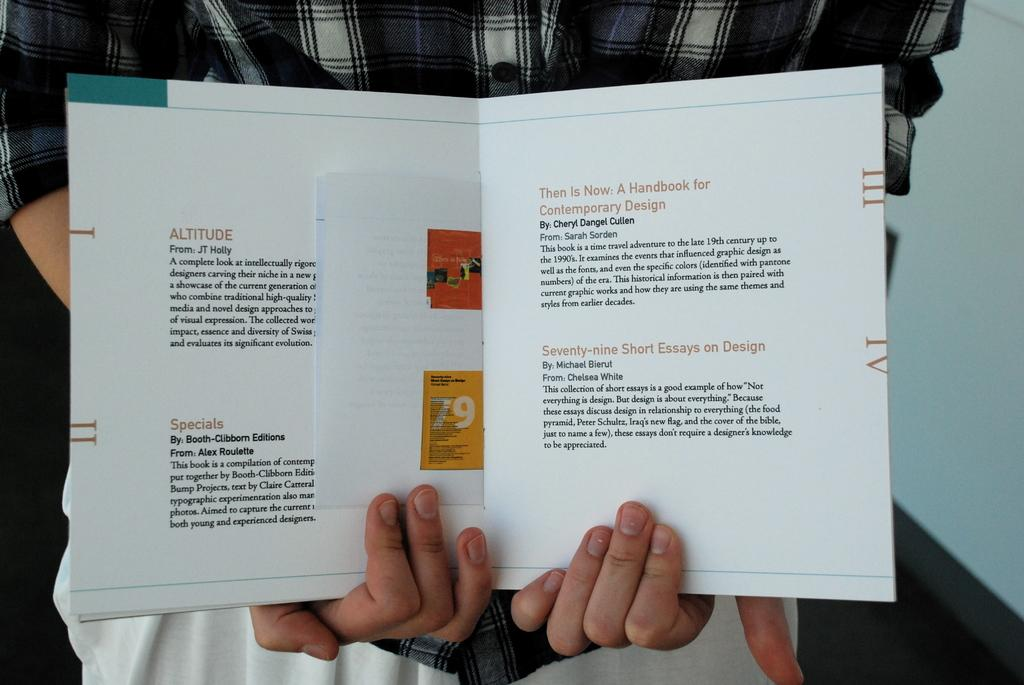<image>
Summarize the visual content of the image. A book is held open and a heading on view is titled altitude 